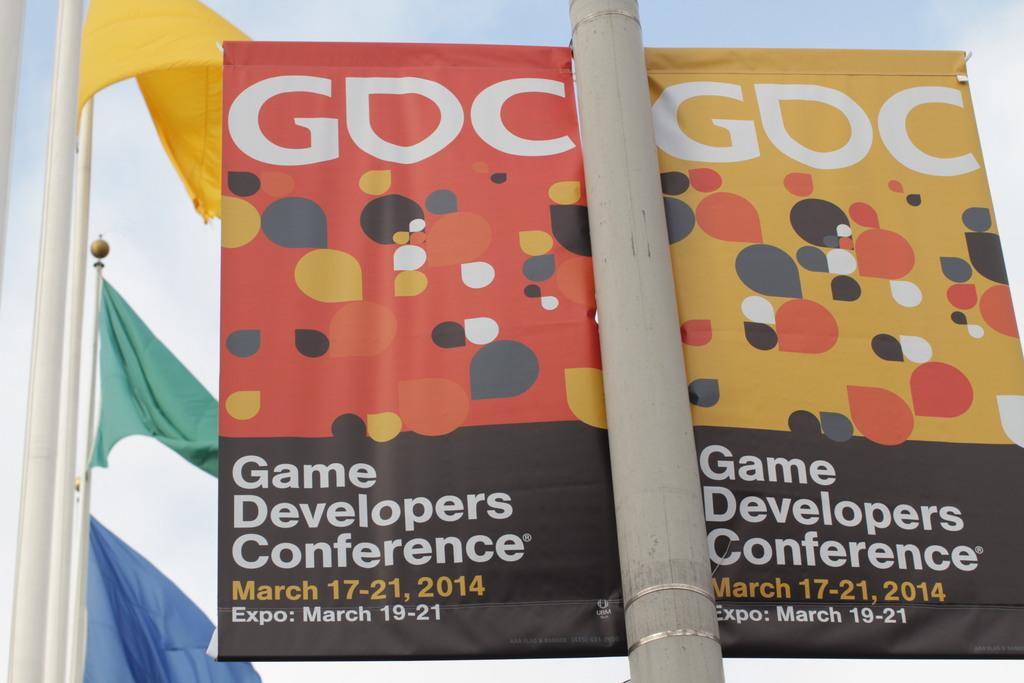<image>
Describe the image concisely. A sign hangs advertising a game developers conference in March. 